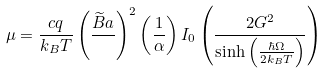Convert formula to latex. <formula><loc_0><loc_0><loc_500><loc_500>\mu = \frac { c q } { k _ { B } T } \left ( \frac { \widetilde { B } a } { } \right ) ^ { 2 } \left ( \frac { 1 } { \alpha } \right ) I _ { 0 } \left ( \frac { 2 G ^ { 2 } } { \sinh \left ( \frac { \hbar { \Omega } } { 2 k _ { B } T } \right ) } \right )</formula> 